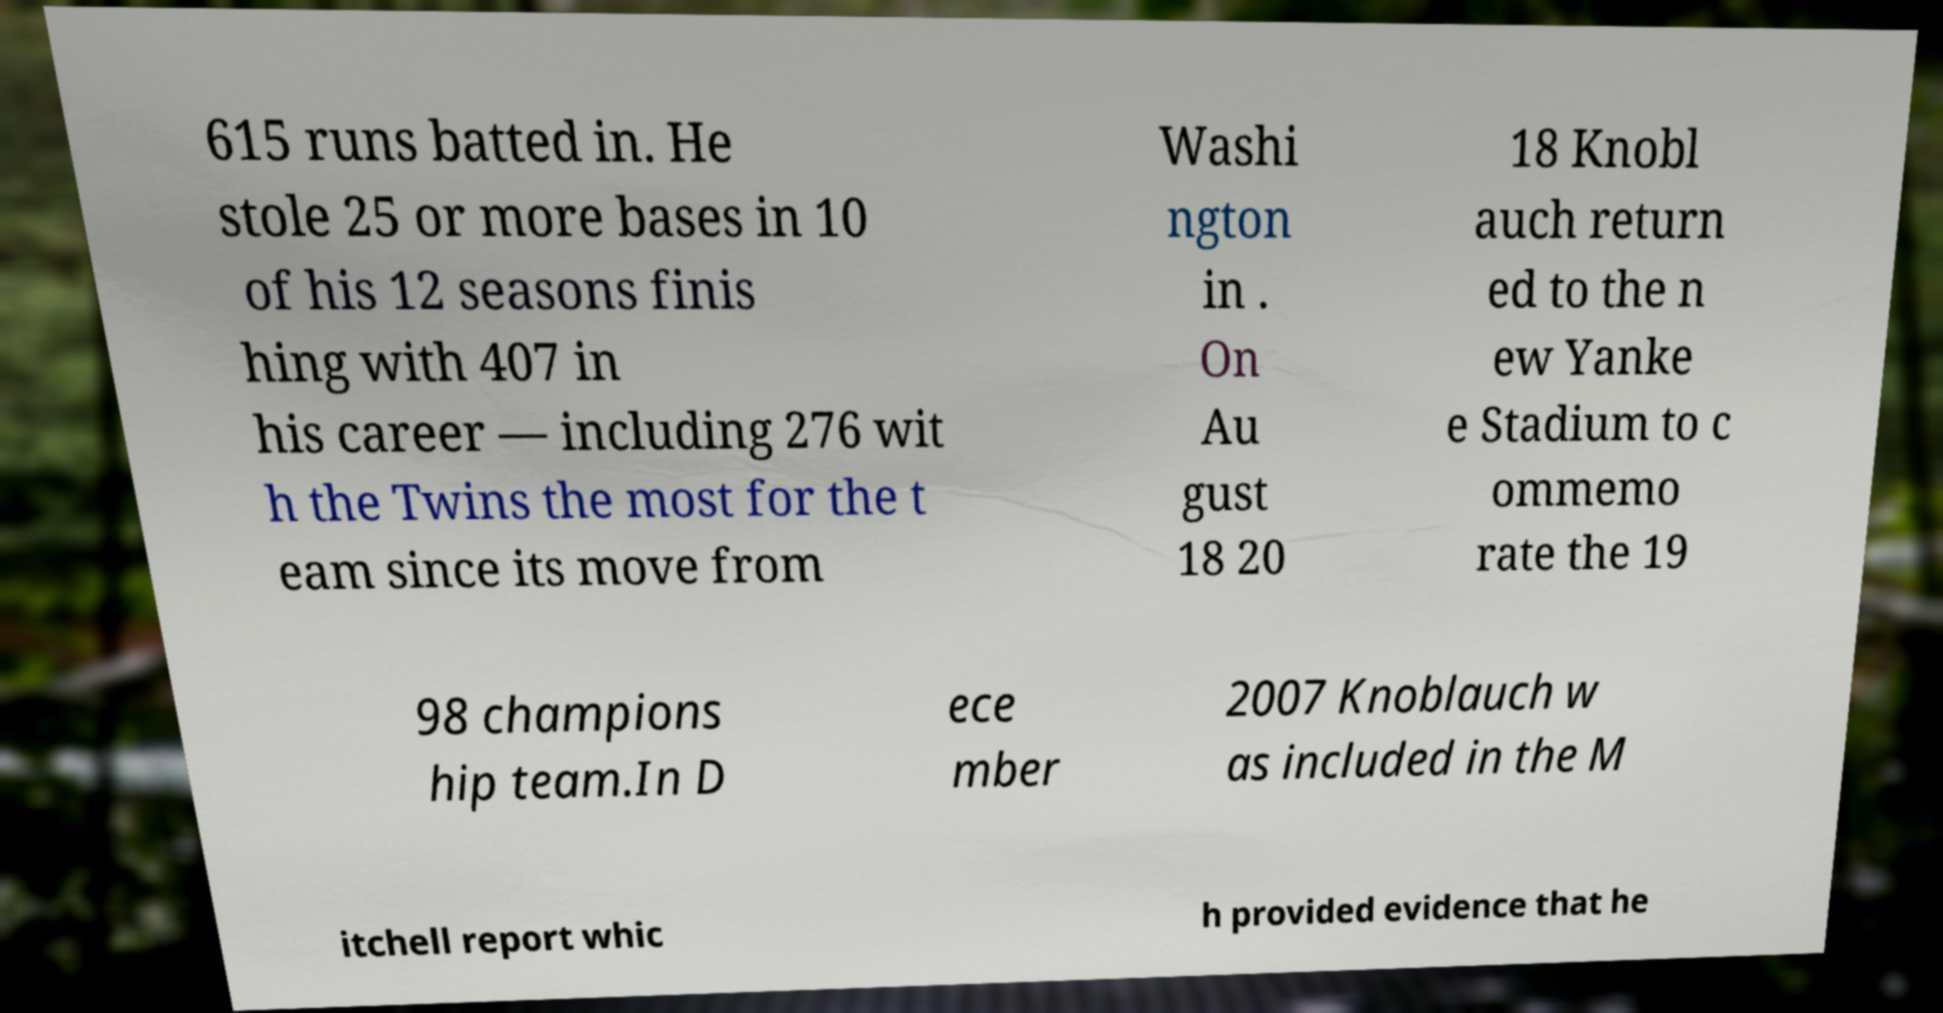For documentation purposes, I need the text within this image transcribed. Could you provide that? 615 runs batted in. He stole 25 or more bases in 10 of his 12 seasons finis hing with 407 in his career — including 276 wit h the Twins the most for the t eam since its move from Washi ngton in . On Au gust 18 20 18 Knobl auch return ed to the n ew Yanke e Stadium to c ommemo rate the 19 98 champions hip team.In D ece mber 2007 Knoblauch w as included in the M itchell report whic h provided evidence that he 